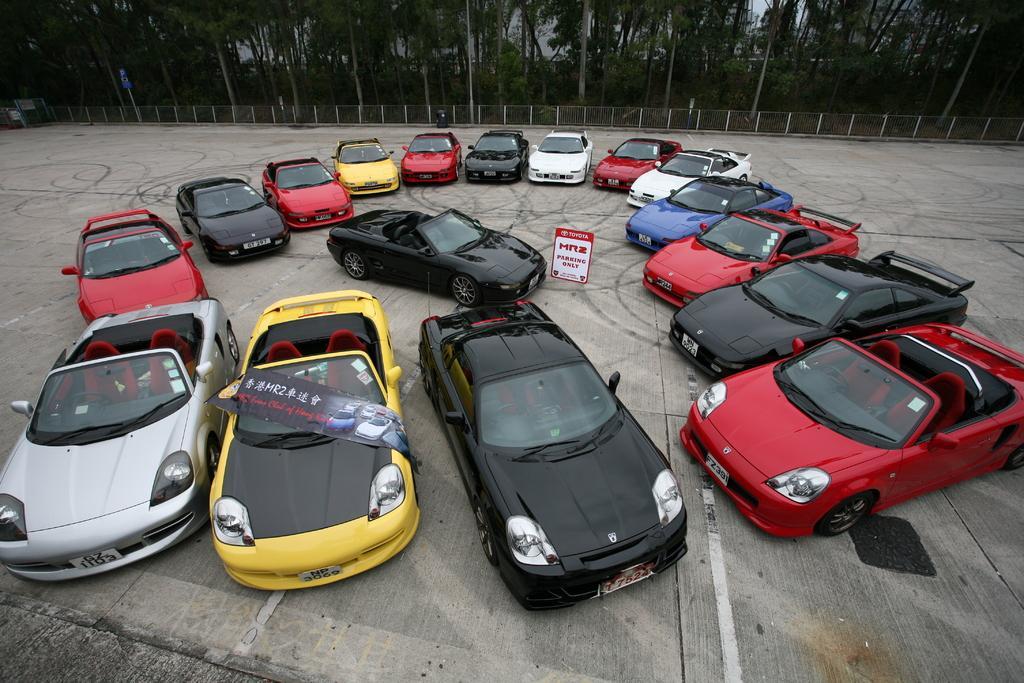Describe this image in one or two sentences. In the center of the image we can see cars and board. In the background of the image we can see mesh, trees. At the bottom of the image there is a ground. 